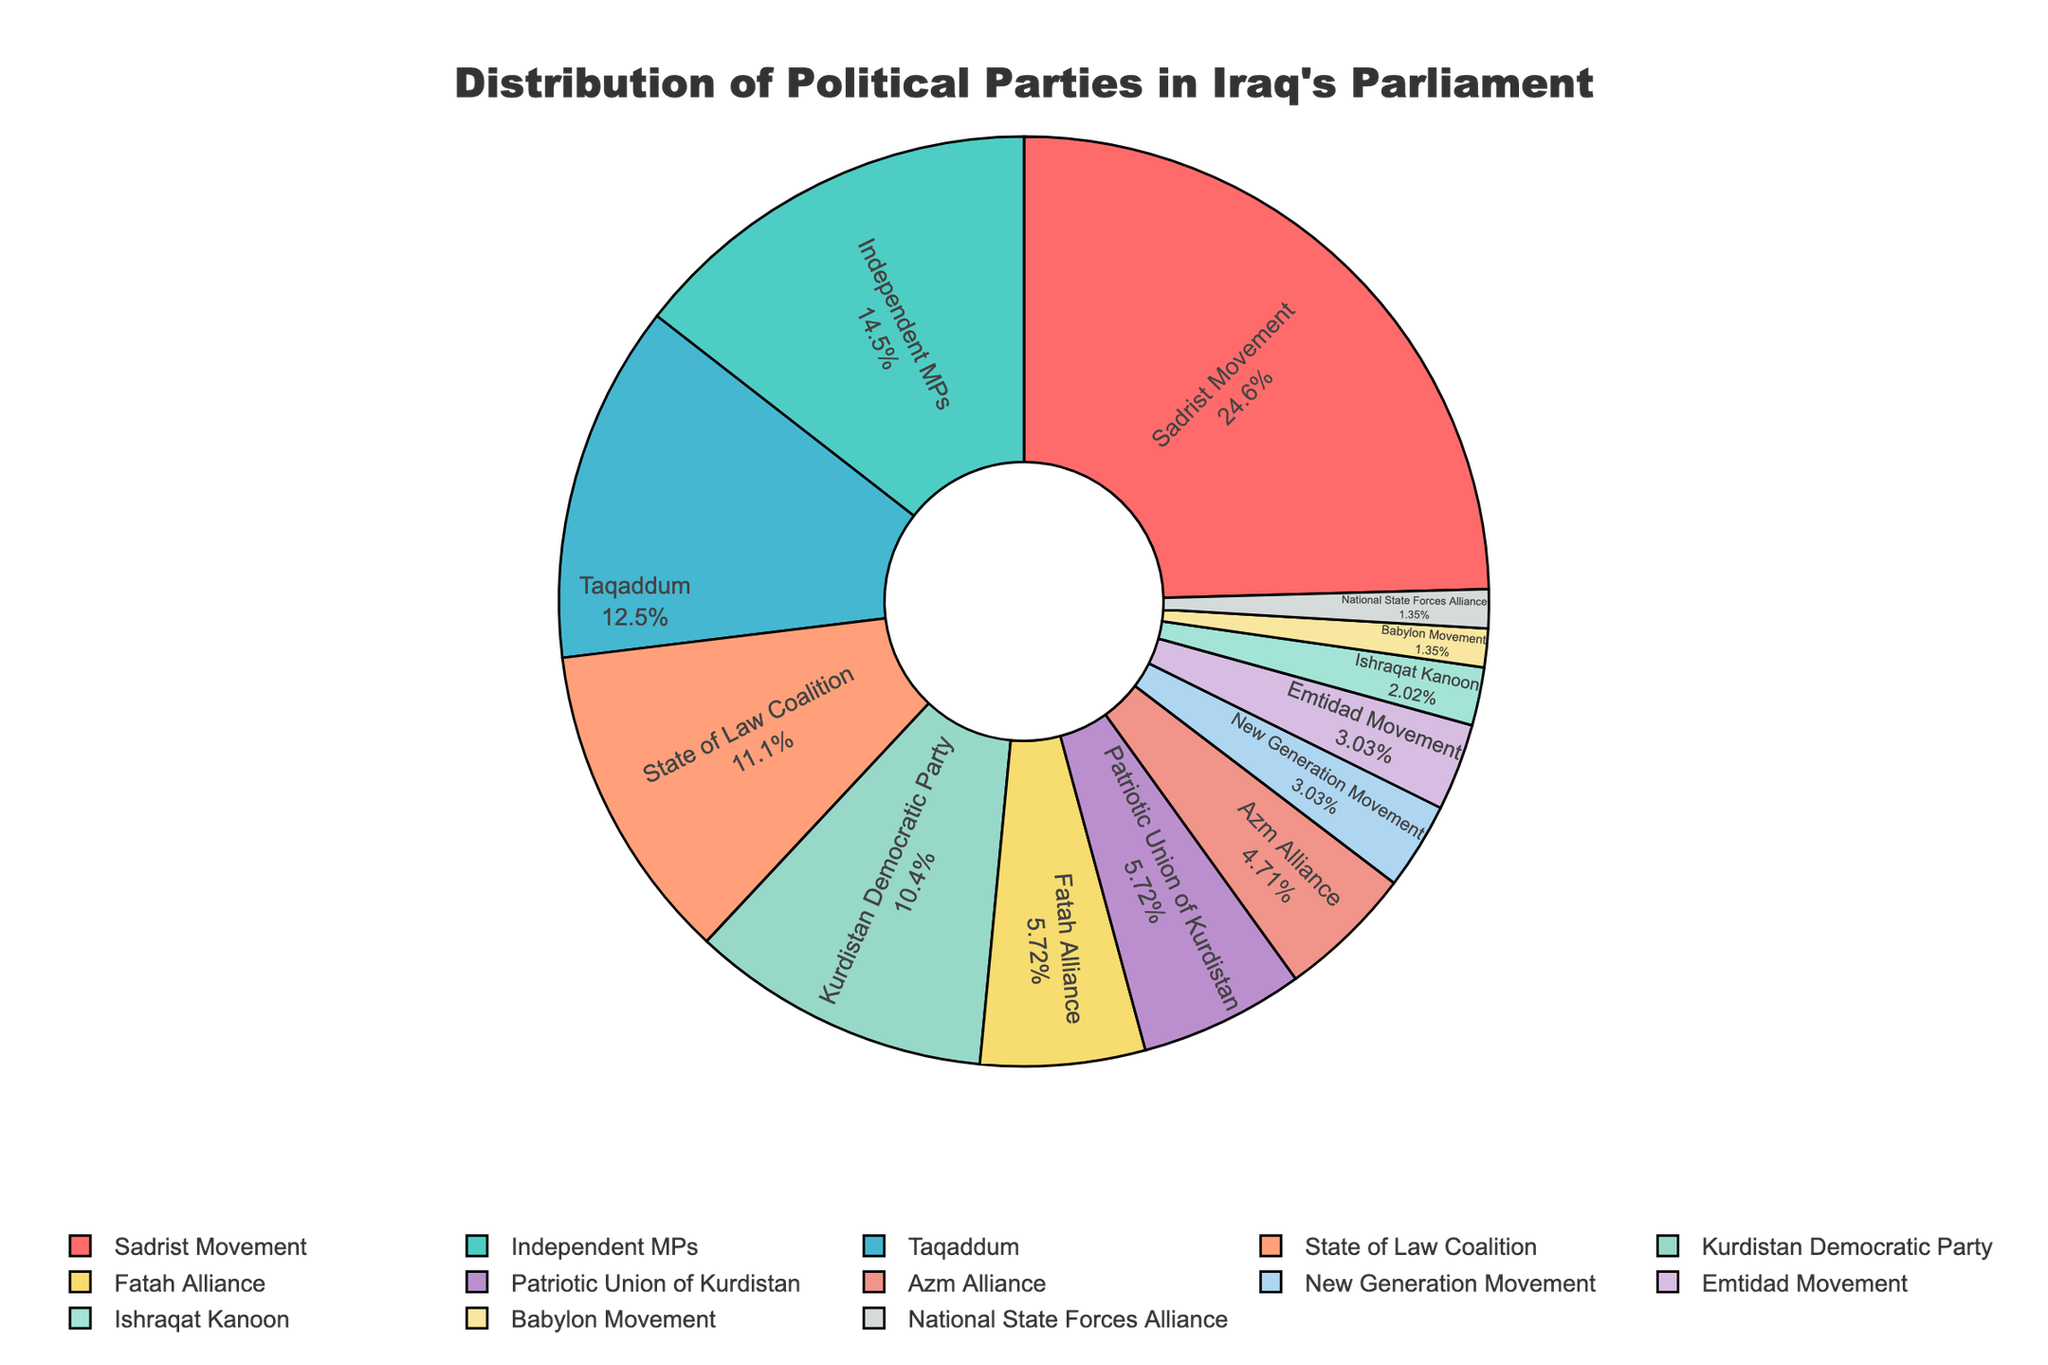Which party has the most seats in Iraq's parliament? The largest segment of the pie chart corresponds to the Sadrist Movement. This visual cue indicates that the Sadrist Movement leads in terms of the number of seats.
Answer: Sadrist Movement How many more seats does the Sadrist Movement have compared to Taqaddum? The Sadrist Movement has 73 seats, and Taqaddum has 37 seats. The difference is calculated by subtracting 37 from 73.
Answer: 36 What percentage of seats do the Kurdish parties (KDP and PUK combined) hold? The Kurdistan Democratic Party (KDP) has 31 seats, and the Patriotic Union of Kurdistan (PUK) has 17 seats. First, sum these numbers: 31 + 17 = 48. To find the percentage, divide 48 by the total number of seats (329) and multiply by 100.
Answer: 14.6% Which color represents the Fatah Alliance, and how many seats do they have? The Fatah Alliance is represented by the greenish-blue segment in the pie chart. By closely examining the labels and corresponding colors, it can be seen that this segment corresponds to 17 seats.
Answer: Greenish-blue, 17 seats Compare the number of seats held by Independent MPs and the State of Law Coalition. Which group has more, and by how many? Independent MPs have 43 seats, while the State of Law Coalition has 33 seats. Subtracting 33 from 43 gives the difference.
Answer: Independent MPs have 10 more seats How many seats are held by parties with fewer than 10 seats each? Sum the seats of the parties with fewer than 10 seats: New Generation Movement (9), Emtidad Movement (9), Babylon Movement (4), National State Forces Alliance (4), and Ishraqat Kanoon (6). Add these numbers: 9 + 9 + 4 + 4 + 6 = 32.
Answer: 32 What is the total number of seats held by the top three parties combined? The top three parties are Sadrist Movement with 73 seats, Taqaddum with 37 seats, and Independent MPs with 43 seats. Sum these numbers: 73 + 37 + 43 = 153.
Answer: 153 What is the percentage difference between the seats held by Azm Alliance and the highest-seated party? The Sadrist Movement holds 73 seats, while the Azm Alliance holds 14. First, find the difference: 73 - 14 = 59. Then, calculate the percentage difference based on the highest number of seats: (59 / 73) * 100.
Answer: 80.8% Which party with the least number of seats and what is that number? By identifying the smallest segment in the pie chart, it's clear that the parties with the least number of seats are Babylon Movement and National State Forces Alliance, each with 4 seats.
Answer: Babylon Movement and National State Forces Alliance, 4 seats Compare the total number of seats held by the three Kurdish parties (KDP, PUK, and New Generation Movement) with those held by the Sadrist Movement. Who has more and by how many? Sum the seats of KDP (31), PUK (17), and New Generation Movement (9): 31 + 17 + 9 = 57. The Sadrist Movement has 73 seats. Subtract the total Kurdish seats from the Sadrist Movement's seats: 73 - 57 = 16.
Answer: Sadrist Movement by 16 seats 